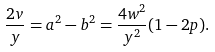<formula> <loc_0><loc_0><loc_500><loc_500>\frac { 2 v } { y } = a ^ { 2 } - b ^ { 2 } = \frac { 4 w ^ { 2 } } { y ^ { 2 } } ( 1 - 2 p ) .</formula> 